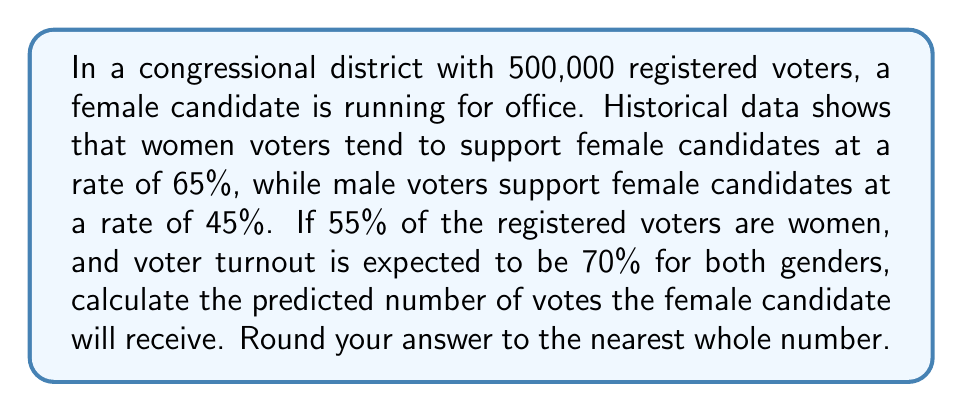Can you solve this math problem? Let's break this problem down step-by-step:

1. Calculate the number of registered women and men voters:
   Women: $500,000 \times 0.55 = 275,000$
   Men: $500,000 \times 0.45 = 225,000$

2. Calculate the expected turnout for each gender:
   Women turnout: $275,000 \times 0.70 = 192,500$
   Men turnout: $225,000 \times 0.70 = 157,500$

3. Calculate the number of votes from women:
   $192,500 \times 0.65 = 125,125$

4. Calculate the number of votes from men:
   $157,500 \times 0.45 = 70,875$

5. Sum up the total votes for the female candidate:
   $125,125 + 70,875 = 196,000$

The predicted number of votes for the female candidate is 196,000.
Answer: 196,000 votes 